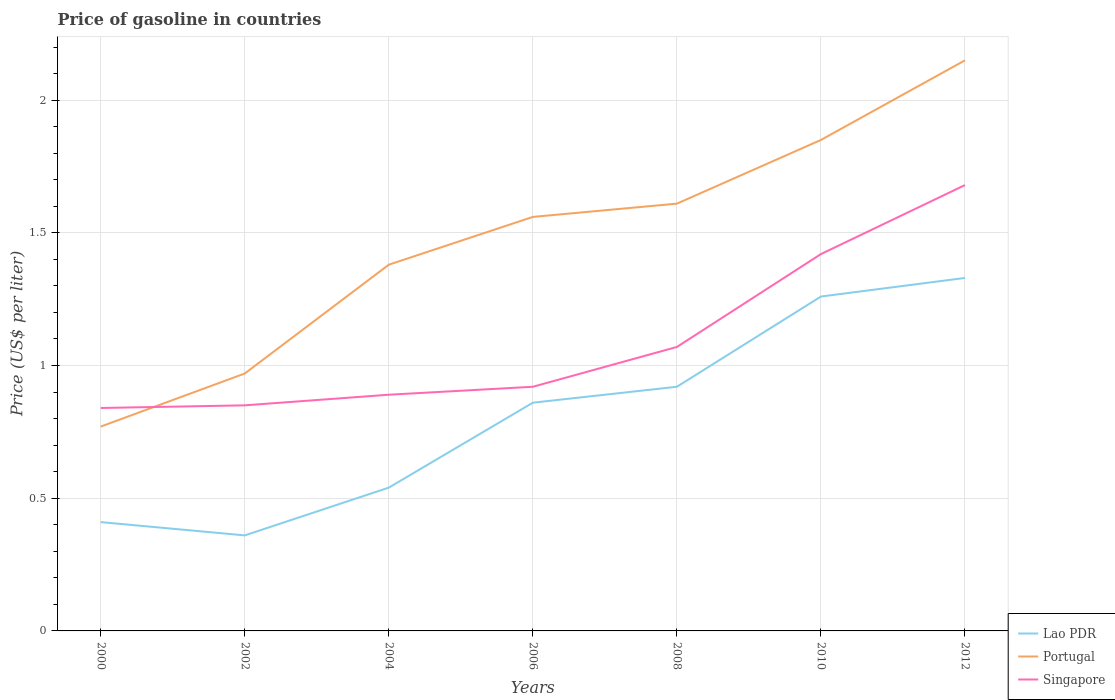How many different coloured lines are there?
Provide a succinct answer. 3. Across all years, what is the maximum price of gasoline in Lao PDR?
Make the answer very short. 0.36. What is the total price of gasoline in Singapore in the graph?
Your answer should be very brief. -0.08. What is the difference between the highest and the second highest price of gasoline in Portugal?
Your response must be concise. 1.38. Is the price of gasoline in Singapore strictly greater than the price of gasoline in Portugal over the years?
Give a very brief answer. No. Does the graph contain any zero values?
Ensure brevity in your answer.  No. Does the graph contain grids?
Provide a short and direct response. Yes. Where does the legend appear in the graph?
Provide a short and direct response. Bottom right. How many legend labels are there?
Your answer should be very brief. 3. What is the title of the graph?
Provide a succinct answer. Price of gasoline in countries. What is the label or title of the X-axis?
Your answer should be very brief. Years. What is the label or title of the Y-axis?
Provide a short and direct response. Price (US$ per liter). What is the Price (US$ per liter) of Lao PDR in 2000?
Provide a succinct answer. 0.41. What is the Price (US$ per liter) of Portugal in 2000?
Ensure brevity in your answer.  0.77. What is the Price (US$ per liter) of Singapore in 2000?
Provide a short and direct response. 0.84. What is the Price (US$ per liter) of Lao PDR in 2002?
Give a very brief answer. 0.36. What is the Price (US$ per liter) in Portugal in 2002?
Offer a very short reply. 0.97. What is the Price (US$ per liter) in Singapore in 2002?
Offer a terse response. 0.85. What is the Price (US$ per liter) in Lao PDR in 2004?
Your answer should be compact. 0.54. What is the Price (US$ per liter) of Portugal in 2004?
Make the answer very short. 1.38. What is the Price (US$ per liter) of Singapore in 2004?
Your answer should be very brief. 0.89. What is the Price (US$ per liter) of Lao PDR in 2006?
Make the answer very short. 0.86. What is the Price (US$ per liter) in Portugal in 2006?
Your answer should be very brief. 1.56. What is the Price (US$ per liter) of Singapore in 2006?
Your answer should be very brief. 0.92. What is the Price (US$ per liter) in Portugal in 2008?
Your response must be concise. 1.61. What is the Price (US$ per liter) of Singapore in 2008?
Keep it short and to the point. 1.07. What is the Price (US$ per liter) in Lao PDR in 2010?
Your answer should be compact. 1.26. What is the Price (US$ per liter) in Portugal in 2010?
Make the answer very short. 1.85. What is the Price (US$ per liter) of Singapore in 2010?
Offer a terse response. 1.42. What is the Price (US$ per liter) in Lao PDR in 2012?
Ensure brevity in your answer.  1.33. What is the Price (US$ per liter) in Portugal in 2012?
Offer a terse response. 2.15. What is the Price (US$ per liter) of Singapore in 2012?
Your response must be concise. 1.68. Across all years, what is the maximum Price (US$ per liter) of Lao PDR?
Make the answer very short. 1.33. Across all years, what is the maximum Price (US$ per liter) of Portugal?
Your response must be concise. 2.15. Across all years, what is the maximum Price (US$ per liter) in Singapore?
Provide a short and direct response. 1.68. Across all years, what is the minimum Price (US$ per liter) of Lao PDR?
Your answer should be compact. 0.36. Across all years, what is the minimum Price (US$ per liter) in Portugal?
Make the answer very short. 0.77. Across all years, what is the minimum Price (US$ per liter) of Singapore?
Provide a succinct answer. 0.84. What is the total Price (US$ per liter) of Lao PDR in the graph?
Make the answer very short. 5.68. What is the total Price (US$ per liter) in Portugal in the graph?
Provide a short and direct response. 10.29. What is the total Price (US$ per liter) in Singapore in the graph?
Make the answer very short. 7.67. What is the difference between the Price (US$ per liter) of Lao PDR in 2000 and that in 2002?
Offer a very short reply. 0.05. What is the difference between the Price (US$ per liter) in Singapore in 2000 and that in 2002?
Ensure brevity in your answer.  -0.01. What is the difference between the Price (US$ per liter) in Lao PDR in 2000 and that in 2004?
Your response must be concise. -0.13. What is the difference between the Price (US$ per liter) of Portugal in 2000 and that in 2004?
Your response must be concise. -0.61. What is the difference between the Price (US$ per liter) in Lao PDR in 2000 and that in 2006?
Provide a succinct answer. -0.45. What is the difference between the Price (US$ per liter) in Portugal in 2000 and that in 2006?
Provide a succinct answer. -0.79. What is the difference between the Price (US$ per liter) in Singapore in 2000 and that in 2006?
Provide a succinct answer. -0.08. What is the difference between the Price (US$ per liter) of Lao PDR in 2000 and that in 2008?
Provide a short and direct response. -0.51. What is the difference between the Price (US$ per liter) of Portugal in 2000 and that in 2008?
Your answer should be compact. -0.84. What is the difference between the Price (US$ per liter) in Singapore in 2000 and that in 2008?
Provide a short and direct response. -0.23. What is the difference between the Price (US$ per liter) of Lao PDR in 2000 and that in 2010?
Give a very brief answer. -0.85. What is the difference between the Price (US$ per liter) of Portugal in 2000 and that in 2010?
Your answer should be compact. -1.08. What is the difference between the Price (US$ per liter) of Singapore in 2000 and that in 2010?
Make the answer very short. -0.58. What is the difference between the Price (US$ per liter) in Lao PDR in 2000 and that in 2012?
Make the answer very short. -0.92. What is the difference between the Price (US$ per liter) of Portugal in 2000 and that in 2012?
Your answer should be compact. -1.38. What is the difference between the Price (US$ per liter) in Singapore in 2000 and that in 2012?
Offer a very short reply. -0.84. What is the difference between the Price (US$ per liter) in Lao PDR in 2002 and that in 2004?
Your response must be concise. -0.18. What is the difference between the Price (US$ per liter) of Portugal in 2002 and that in 2004?
Your answer should be very brief. -0.41. What is the difference between the Price (US$ per liter) of Singapore in 2002 and that in 2004?
Ensure brevity in your answer.  -0.04. What is the difference between the Price (US$ per liter) of Lao PDR in 2002 and that in 2006?
Keep it short and to the point. -0.5. What is the difference between the Price (US$ per liter) of Portugal in 2002 and that in 2006?
Provide a succinct answer. -0.59. What is the difference between the Price (US$ per liter) in Singapore in 2002 and that in 2006?
Keep it short and to the point. -0.07. What is the difference between the Price (US$ per liter) of Lao PDR in 2002 and that in 2008?
Make the answer very short. -0.56. What is the difference between the Price (US$ per liter) of Portugal in 2002 and that in 2008?
Your answer should be very brief. -0.64. What is the difference between the Price (US$ per liter) in Singapore in 2002 and that in 2008?
Provide a succinct answer. -0.22. What is the difference between the Price (US$ per liter) of Lao PDR in 2002 and that in 2010?
Keep it short and to the point. -0.9. What is the difference between the Price (US$ per liter) in Portugal in 2002 and that in 2010?
Provide a succinct answer. -0.88. What is the difference between the Price (US$ per liter) in Singapore in 2002 and that in 2010?
Give a very brief answer. -0.57. What is the difference between the Price (US$ per liter) in Lao PDR in 2002 and that in 2012?
Your answer should be very brief. -0.97. What is the difference between the Price (US$ per liter) of Portugal in 2002 and that in 2012?
Provide a succinct answer. -1.18. What is the difference between the Price (US$ per liter) in Singapore in 2002 and that in 2012?
Keep it short and to the point. -0.83. What is the difference between the Price (US$ per liter) in Lao PDR in 2004 and that in 2006?
Offer a very short reply. -0.32. What is the difference between the Price (US$ per liter) of Portugal in 2004 and that in 2006?
Your answer should be compact. -0.18. What is the difference between the Price (US$ per liter) in Singapore in 2004 and that in 2006?
Make the answer very short. -0.03. What is the difference between the Price (US$ per liter) in Lao PDR in 2004 and that in 2008?
Ensure brevity in your answer.  -0.38. What is the difference between the Price (US$ per liter) of Portugal in 2004 and that in 2008?
Your answer should be compact. -0.23. What is the difference between the Price (US$ per liter) in Singapore in 2004 and that in 2008?
Your answer should be compact. -0.18. What is the difference between the Price (US$ per liter) of Lao PDR in 2004 and that in 2010?
Make the answer very short. -0.72. What is the difference between the Price (US$ per liter) in Portugal in 2004 and that in 2010?
Make the answer very short. -0.47. What is the difference between the Price (US$ per liter) of Singapore in 2004 and that in 2010?
Offer a very short reply. -0.53. What is the difference between the Price (US$ per liter) of Lao PDR in 2004 and that in 2012?
Provide a short and direct response. -0.79. What is the difference between the Price (US$ per liter) of Portugal in 2004 and that in 2012?
Make the answer very short. -0.77. What is the difference between the Price (US$ per liter) of Singapore in 2004 and that in 2012?
Your response must be concise. -0.79. What is the difference between the Price (US$ per liter) of Lao PDR in 2006 and that in 2008?
Offer a terse response. -0.06. What is the difference between the Price (US$ per liter) of Singapore in 2006 and that in 2008?
Give a very brief answer. -0.15. What is the difference between the Price (US$ per liter) in Lao PDR in 2006 and that in 2010?
Make the answer very short. -0.4. What is the difference between the Price (US$ per liter) of Portugal in 2006 and that in 2010?
Provide a short and direct response. -0.29. What is the difference between the Price (US$ per liter) of Singapore in 2006 and that in 2010?
Make the answer very short. -0.5. What is the difference between the Price (US$ per liter) of Lao PDR in 2006 and that in 2012?
Your answer should be compact. -0.47. What is the difference between the Price (US$ per liter) of Portugal in 2006 and that in 2012?
Keep it short and to the point. -0.59. What is the difference between the Price (US$ per liter) in Singapore in 2006 and that in 2012?
Offer a terse response. -0.76. What is the difference between the Price (US$ per liter) in Lao PDR in 2008 and that in 2010?
Make the answer very short. -0.34. What is the difference between the Price (US$ per liter) of Portugal in 2008 and that in 2010?
Keep it short and to the point. -0.24. What is the difference between the Price (US$ per liter) of Singapore in 2008 and that in 2010?
Make the answer very short. -0.35. What is the difference between the Price (US$ per liter) of Lao PDR in 2008 and that in 2012?
Ensure brevity in your answer.  -0.41. What is the difference between the Price (US$ per liter) of Portugal in 2008 and that in 2012?
Your response must be concise. -0.54. What is the difference between the Price (US$ per liter) in Singapore in 2008 and that in 2012?
Make the answer very short. -0.61. What is the difference between the Price (US$ per liter) of Lao PDR in 2010 and that in 2012?
Ensure brevity in your answer.  -0.07. What is the difference between the Price (US$ per liter) in Singapore in 2010 and that in 2012?
Your response must be concise. -0.26. What is the difference between the Price (US$ per liter) of Lao PDR in 2000 and the Price (US$ per liter) of Portugal in 2002?
Give a very brief answer. -0.56. What is the difference between the Price (US$ per liter) of Lao PDR in 2000 and the Price (US$ per liter) of Singapore in 2002?
Give a very brief answer. -0.44. What is the difference between the Price (US$ per liter) of Portugal in 2000 and the Price (US$ per liter) of Singapore in 2002?
Give a very brief answer. -0.08. What is the difference between the Price (US$ per liter) of Lao PDR in 2000 and the Price (US$ per liter) of Portugal in 2004?
Offer a terse response. -0.97. What is the difference between the Price (US$ per liter) in Lao PDR in 2000 and the Price (US$ per liter) in Singapore in 2004?
Ensure brevity in your answer.  -0.48. What is the difference between the Price (US$ per liter) of Portugal in 2000 and the Price (US$ per liter) of Singapore in 2004?
Ensure brevity in your answer.  -0.12. What is the difference between the Price (US$ per liter) of Lao PDR in 2000 and the Price (US$ per liter) of Portugal in 2006?
Your answer should be compact. -1.15. What is the difference between the Price (US$ per liter) of Lao PDR in 2000 and the Price (US$ per liter) of Singapore in 2006?
Make the answer very short. -0.51. What is the difference between the Price (US$ per liter) of Portugal in 2000 and the Price (US$ per liter) of Singapore in 2006?
Provide a short and direct response. -0.15. What is the difference between the Price (US$ per liter) of Lao PDR in 2000 and the Price (US$ per liter) of Singapore in 2008?
Provide a succinct answer. -0.66. What is the difference between the Price (US$ per liter) in Portugal in 2000 and the Price (US$ per liter) in Singapore in 2008?
Ensure brevity in your answer.  -0.3. What is the difference between the Price (US$ per liter) in Lao PDR in 2000 and the Price (US$ per liter) in Portugal in 2010?
Keep it short and to the point. -1.44. What is the difference between the Price (US$ per liter) of Lao PDR in 2000 and the Price (US$ per liter) of Singapore in 2010?
Ensure brevity in your answer.  -1.01. What is the difference between the Price (US$ per liter) in Portugal in 2000 and the Price (US$ per liter) in Singapore in 2010?
Your answer should be compact. -0.65. What is the difference between the Price (US$ per liter) in Lao PDR in 2000 and the Price (US$ per liter) in Portugal in 2012?
Offer a very short reply. -1.74. What is the difference between the Price (US$ per liter) of Lao PDR in 2000 and the Price (US$ per liter) of Singapore in 2012?
Your answer should be very brief. -1.27. What is the difference between the Price (US$ per liter) of Portugal in 2000 and the Price (US$ per liter) of Singapore in 2012?
Your answer should be very brief. -0.91. What is the difference between the Price (US$ per liter) of Lao PDR in 2002 and the Price (US$ per liter) of Portugal in 2004?
Provide a short and direct response. -1.02. What is the difference between the Price (US$ per liter) in Lao PDR in 2002 and the Price (US$ per liter) in Singapore in 2004?
Offer a very short reply. -0.53. What is the difference between the Price (US$ per liter) of Portugal in 2002 and the Price (US$ per liter) of Singapore in 2004?
Your response must be concise. 0.08. What is the difference between the Price (US$ per liter) in Lao PDR in 2002 and the Price (US$ per liter) in Singapore in 2006?
Provide a succinct answer. -0.56. What is the difference between the Price (US$ per liter) of Lao PDR in 2002 and the Price (US$ per liter) of Portugal in 2008?
Make the answer very short. -1.25. What is the difference between the Price (US$ per liter) of Lao PDR in 2002 and the Price (US$ per liter) of Singapore in 2008?
Make the answer very short. -0.71. What is the difference between the Price (US$ per liter) of Portugal in 2002 and the Price (US$ per liter) of Singapore in 2008?
Your answer should be compact. -0.1. What is the difference between the Price (US$ per liter) in Lao PDR in 2002 and the Price (US$ per liter) in Portugal in 2010?
Provide a short and direct response. -1.49. What is the difference between the Price (US$ per liter) in Lao PDR in 2002 and the Price (US$ per liter) in Singapore in 2010?
Offer a very short reply. -1.06. What is the difference between the Price (US$ per liter) in Portugal in 2002 and the Price (US$ per liter) in Singapore in 2010?
Your response must be concise. -0.45. What is the difference between the Price (US$ per liter) of Lao PDR in 2002 and the Price (US$ per liter) of Portugal in 2012?
Provide a short and direct response. -1.79. What is the difference between the Price (US$ per liter) in Lao PDR in 2002 and the Price (US$ per liter) in Singapore in 2012?
Make the answer very short. -1.32. What is the difference between the Price (US$ per liter) in Portugal in 2002 and the Price (US$ per liter) in Singapore in 2012?
Offer a very short reply. -0.71. What is the difference between the Price (US$ per liter) of Lao PDR in 2004 and the Price (US$ per liter) of Portugal in 2006?
Give a very brief answer. -1.02. What is the difference between the Price (US$ per liter) in Lao PDR in 2004 and the Price (US$ per liter) in Singapore in 2006?
Your answer should be compact. -0.38. What is the difference between the Price (US$ per liter) of Portugal in 2004 and the Price (US$ per liter) of Singapore in 2006?
Offer a terse response. 0.46. What is the difference between the Price (US$ per liter) of Lao PDR in 2004 and the Price (US$ per liter) of Portugal in 2008?
Your answer should be compact. -1.07. What is the difference between the Price (US$ per liter) of Lao PDR in 2004 and the Price (US$ per liter) of Singapore in 2008?
Make the answer very short. -0.53. What is the difference between the Price (US$ per liter) of Portugal in 2004 and the Price (US$ per liter) of Singapore in 2008?
Offer a very short reply. 0.31. What is the difference between the Price (US$ per liter) of Lao PDR in 2004 and the Price (US$ per liter) of Portugal in 2010?
Make the answer very short. -1.31. What is the difference between the Price (US$ per liter) of Lao PDR in 2004 and the Price (US$ per liter) of Singapore in 2010?
Give a very brief answer. -0.88. What is the difference between the Price (US$ per liter) of Portugal in 2004 and the Price (US$ per liter) of Singapore in 2010?
Provide a succinct answer. -0.04. What is the difference between the Price (US$ per liter) in Lao PDR in 2004 and the Price (US$ per liter) in Portugal in 2012?
Provide a short and direct response. -1.61. What is the difference between the Price (US$ per liter) in Lao PDR in 2004 and the Price (US$ per liter) in Singapore in 2012?
Your answer should be compact. -1.14. What is the difference between the Price (US$ per liter) in Lao PDR in 2006 and the Price (US$ per liter) in Portugal in 2008?
Provide a succinct answer. -0.75. What is the difference between the Price (US$ per liter) of Lao PDR in 2006 and the Price (US$ per liter) of Singapore in 2008?
Offer a terse response. -0.21. What is the difference between the Price (US$ per liter) of Portugal in 2006 and the Price (US$ per liter) of Singapore in 2008?
Your answer should be compact. 0.49. What is the difference between the Price (US$ per liter) of Lao PDR in 2006 and the Price (US$ per liter) of Portugal in 2010?
Your answer should be very brief. -0.99. What is the difference between the Price (US$ per liter) of Lao PDR in 2006 and the Price (US$ per liter) of Singapore in 2010?
Keep it short and to the point. -0.56. What is the difference between the Price (US$ per liter) of Portugal in 2006 and the Price (US$ per liter) of Singapore in 2010?
Ensure brevity in your answer.  0.14. What is the difference between the Price (US$ per liter) of Lao PDR in 2006 and the Price (US$ per liter) of Portugal in 2012?
Offer a very short reply. -1.29. What is the difference between the Price (US$ per liter) in Lao PDR in 2006 and the Price (US$ per liter) in Singapore in 2012?
Offer a terse response. -0.82. What is the difference between the Price (US$ per liter) in Portugal in 2006 and the Price (US$ per liter) in Singapore in 2012?
Give a very brief answer. -0.12. What is the difference between the Price (US$ per liter) of Lao PDR in 2008 and the Price (US$ per liter) of Portugal in 2010?
Your response must be concise. -0.93. What is the difference between the Price (US$ per liter) of Portugal in 2008 and the Price (US$ per liter) of Singapore in 2010?
Give a very brief answer. 0.19. What is the difference between the Price (US$ per liter) of Lao PDR in 2008 and the Price (US$ per liter) of Portugal in 2012?
Ensure brevity in your answer.  -1.23. What is the difference between the Price (US$ per liter) in Lao PDR in 2008 and the Price (US$ per liter) in Singapore in 2012?
Offer a very short reply. -0.76. What is the difference between the Price (US$ per liter) of Portugal in 2008 and the Price (US$ per liter) of Singapore in 2012?
Keep it short and to the point. -0.07. What is the difference between the Price (US$ per liter) of Lao PDR in 2010 and the Price (US$ per liter) of Portugal in 2012?
Offer a terse response. -0.89. What is the difference between the Price (US$ per liter) of Lao PDR in 2010 and the Price (US$ per liter) of Singapore in 2012?
Provide a short and direct response. -0.42. What is the difference between the Price (US$ per liter) in Portugal in 2010 and the Price (US$ per liter) in Singapore in 2012?
Ensure brevity in your answer.  0.17. What is the average Price (US$ per liter) of Lao PDR per year?
Provide a succinct answer. 0.81. What is the average Price (US$ per liter) in Portugal per year?
Your response must be concise. 1.47. What is the average Price (US$ per liter) in Singapore per year?
Offer a very short reply. 1.1. In the year 2000, what is the difference between the Price (US$ per liter) in Lao PDR and Price (US$ per liter) in Portugal?
Give a very brief answer. -0.36. In the year 2000, what is the difference between the Price (US$ per liter) of Lao PDR and Price (US$ per liter) of Singapore?
Make the answer very short. -0.43. In the year 2000, what is the difference between the Price (US$ per liter) in Portugal and Price (US$ per liter) in Singapore?
Provide a succinct answer. -0.07. In the year 2002, what is the difference between the Price (US$ per liter) in Lao PDR and Price (US$ per liter) in Portugal?
Your answer should be very brief. -0.61. In the year 2002, what is the difference between the Price (US$ per liter) in Lao PDR and Price (US$ per liter) in Singapore?
Provide a short and direct response. -0.49. In the year 2002, what is the difference between the Price (US$ per liter) in Portugal and Price (US$ per liter) in Singapore?
Keep it short and to the point. 0.12. In the year 2004, what is the difference between the Price (US$ per liter) of Lao PDR and Price (US$ per liter) of Portugal?
Offer a terse response. -0.84. In the year 2004, what is the difference between the Price (US$ per liter) in Lao PDR and Price (US$ per liter) in Singapore?
Give a very brief answer. -0.35. In the year 2004, what is the difference between the Price (US$ per liter) of Portugal and Price (US$ per liter) of Singapore?
Keep it short and to the point. 0.49. In the year 2006, what is the difference between the Price (US$ per liter) of Lao PDR and Price (US$ per liter) of Singapore?
Offer a terse response. -0.06. In the year 2006, what is the difference between the Price (US$ per liter) of Portugal and Price (US$ per liter) of Singapore?
Your answer should be very brief. 0.64. In the year 2008, what is the difference between the Price (US$ per liter) of Lao PDR and Price (US$ per liter) of Portugal?
Keep it short and to the point. -0.69. In the year 2008, what is the difference between the Price (US$ per liter) of Portugal and Price (US$ per liter) of Singapore?
Your response must be concise. 0.54. In the year 2010, what is the difference between the Price (US$ per liter) in Lao PDR and Price (US$ per liter) in Portugal?
Give a very brief answer. -0.59. In the year 2010, what is the difference between the Price (US$ per liter) of Lao PDR and Price (US$ per liter) of Singapore?
Your answer should be very brief. -0.16. In the year 2010, what is the difference between the Price (US$ per liter) of Portugal and Price (US$ per liter) of Singapore?
Your answer should be compact. 0.43. In the year 2012, what is the difference between the Price (US$ per liter) in Lao PDR and Price (US$ per liter) in Portugal?
Make the answer very short. -0.82. In the year 2012, what is the difference between the Price (US$ per liter) in Lao PDR and Price (US$ per liter) in Singapore?
Your answer should be very brief. -0.35. In the year 2012, what is the difference between the Price (US$ per liter) in Portugal and Price (US$ per liter) in Singapore?
Make the answer very short. 0.47. What is the ratio of the Price (US$ per liter) in Lao PDR in 2000 to that in 2002?
Provide a short and direct response. 1.14. What is the ratio of the Price (US$ per liter) of Portugal in 2000 to that in 2002?
Give a very brief answer. 0.79. What is the ratio of the Price (US$ per liter) in Lao PDR in 2000 to that in 2004?
Your answer should be compact. 0.76. What is the ratio of the Price (US$ per liter) in Portugal in 2000 to that in 2004?
Your answer should be compact. 0.56. What is the ratio of the Price (US$ per liter) in Singapore in 2000 to that in 2004?
Offer a very short reply. 0.94. What is the ratio of the Price (US$ per liter) in Lao PDR in 2000 to that in 2006?
Offer a very short reply. 0.48. What is the ratio of the Price (US$ per liter) in Portugal in 2000 to that in 2006?
Give a very brief answer. 0.49. What is the ratio of the Price (US$ per liter) in Singapore in 2000 to that in 2006?
Give a very brief answer. 0.91. What is the ratio of the Price (US$ per liter) in Lao PDR in 2000 to that in 2008?
Give a very brief answer. 0.45. What is the ratio of the Price (US$ per liter) in Portugal in 2000 to that in 2008?
Offer a very short reply. 0.48. What is the ratio of the Price (US$ per liter) in Singapore in 2000 to that in 2008?
Your answer should be very brief. 0.79. What is the ratio of the Price (US$ per liter) in Lao PDR in 2000 to that in 2010?
Your answer should be very brief. 0.33. What is the ratio of the Price (US$ per liter) in Portugal in 2000 to that in 2010?
Give a very brief answer. 0.42. What is the ratio of the Price (US$ per liter) in Singapore in 2000 to that in 2010?
Your response must be concise. 0.59. What is the ratio of the Price (US$ per liter) of Lao PDR in 2000 to that in 2012?
Your answer should be very brief. 0.31. What is the ratio of the Price (US$ per liter) in Portugal in 2000 to that in 2012?
Provide a succinct answer. 0.36. What is the ratio of the Price (US$ per liter) in Singapore in 2000 to that in 2012?
Offer a terse response. 0.5. What is the ratio of the Price (US$ per liter) of Portugal in 2002 to that in 2004?
Provide a short and direct response. 0.7. What is the ratio of the Price (US$ per liter) of Singapore in 2002 to that in 2004?
Offer a terse response. 0.96. What is the ratio of the Price (US$ per liter) of Lao PDR in 2002 to that in 2006?
Keep it short and to the point. 0.42. What is the ratio of the Price (US$ per liter) of Portugal in 2002 to that in 2006?
Your answer should be very brief. 0.62. What is the ratio of the Price (US$ per liter) in Singapore in 2002 to that in 2006?
Your response must be concise. 0.92. What is the ratio of the Price (US$ per liter) in Lao PDR in 2002 to that in 2008?
Offer a very short reply. 0.39. What is the ratio of the Price (US$ per liter) in Portugal in 2002 to that in 2008?
Give a very brief answer. 0.6. What is the ratio of the Price (US$ per liter) in Singapore in 2002 to that in 2008?
Give a very brief answer. 0.79. What is the ratio of the Price (US$ per liter) of Lao PDR in 2002 to that in 2010?
Offer a very short reply. 0.29. What is the ratio of the Price (US$ per liter) of Portugal in 2002 to that in 2010?
Ensure brevity in your answer.  0.52. What is the ratio of the Price (US$ per liter) in Singapore in 2002 to that in 2010?
Your answer should be very brief. 0.6. What is the ratio of the Price (US$ per liter) in Lao PDR in 2002 to that in 2012?
Make the answer very short. 0.27. What is the ratio of the Price (US$ per liter) in Portugal in 2002 to that in 2012?
Provide a succinct answer. 0.45. What is the ratio of the Price (US$ per liter) in Singapore in 2002 to that in 2012?
Make the answer very short. 0.51. What is the ratio of the Price (US$ per liter) in Lao PDR in 2004 to that in 2006?
Provide a short and direct response. 0.63. What is the ratio of the Price (US$ per liter) in Portugal in 2004 to that in 2006?
Offer a very short reply. 0.88. What is the ratio of the Price (US$ per liter) of Singapore in 2004 to that in 2006?
Give a very brief answer. 0.97. What is the ratio of the Price (US$ per liter) of Lao PDR in 2004 to that in 2008?
Your answer should be compact. 0.59. What is the ratio of the Price (US$ per liter) of Portugal in 2004 to that in 2008?
Offer a terse response. 0.86. What is the ratio of the Price (US$ per liter) in Singapore in 2004 to that in 2008?
Your response must be concise. 0.83. What is the ratio of the Price (US$ per liter) of Lao PDR in 2004 to that in 2010?
Provide a short and direct response. 0.43. What is the ratio of the Price (US$ per liter) in Portugal in 2004 to that in 2010?
Ensure brevity in your answer.  0.75. What is the ratio of the Price (US$ per liter) in Singapore in 2004 to that in 2010?
Your response must be concise. 0.63. What is the ratio of the Price (US$ per liter) of Lao PDR in 2004 to that in 2012?
Your answer should be very brief. 0.41. What is the ratio of the Price (US$ per liter) of Portugal in 2004 to that in 2012?
Provide a short and direct response. 0.64. What is the ratio of the Price (US$ per liter) in Singapore in 2004 to that in 2012?
Keep it short and to the point. 0.53. What is the ratio of the Price (US$ per liter) of Lao PDR in 2006 to that in 2008?
Provide a succinct answer. 0.93. What is the ratio of the Price (US$ per liter) of Portugal in 2006 to that in 2008?
Keep it short and to the point. 0.97. What is the ratio of the Price (US$ per liter) of Singapore in 2006 to that in 2008?
Your answer should be compact. 0.86. What is the ratio of the Price (US$ per liter) in Lao PDR in 2006 to that in 2010?
Your answer should be compact. 0.68. What is the ratio of the Price (US$ per liter) in Portugal in 2006 to that in 2010?
Your response must be concise. 0.84. What is the ratio of the Price (US$ per liter) of Singapore in 2006 to that in 2010?
Offer a terse response. 0.65. What is the ratio of the Price (US$ per liter) of Lao PDR in 2006 to that in 2012?
Your answer should be very brief. 0.65. What is the ratio of the Price (US$ per liter) in Portugal in 2006 to that in 2012?
Offer a terse response. 0.73. What is the ratio of the Price (US$ per liter) of Singapore in 2006 to that in 2012?
Offer a very short reply. 0.55. What is the ratio of the Price (US$ per liter) of Lao PDR in 2008 to that in 2010?
Provide a succinct answer. 0.73. What is the ratio of the Price (US$ per liter) in Portugal in 2008 to that in 2010?
Give a very brief answer. 0.87. What is the ratio of the Price (US$ per liter) of Singapore in 2008 to that in 2010?
Your response must be concise. 0.75. What is the ratio of the Price (US$ per liter) in Lao PDR in 2008 to that in 2012?
Give a very brief answer. 0.69. What is the ratio of the Price (US$ per liter) of Portugal in 2008 to that in 2012?
Your answer should be compact. 0.75. What is the ratio of the Price (US$ per liter) in Singapore in 2008 to that in 2012?
Your response must be concise. 0.64. What is the ratio of the Price (US$ per liter) of Lao PDR in 2010 to that in 2012?
Your answer should be compact. 0.95. What is the ratio of the Price (US$ per liter) in Portugal in 2010 to that in 2012?
Give a very brief answer. 0.86. What is the ratio of the Price (US$ per liter) in Singapore in 2010 to that in 2012?
Your response must be concise. 0.85. What is the difference between the highest and the second highest Price (US$ per liter) in Lao PDR?
Ensure brevity in your answer.  0.07. What is the difference between the highest and the second highest Price (US$ per liter) of Singapore?
Give a very brief answer. 0.26. What is the difference between the highest and the lowest Price (US$ per liter) of Portugal?
Offer a terse response. 1.38. What is the difference between the highest and the lowest Price (US$ per liter) of Singapore?
Give a very brief answer. 0.84. 